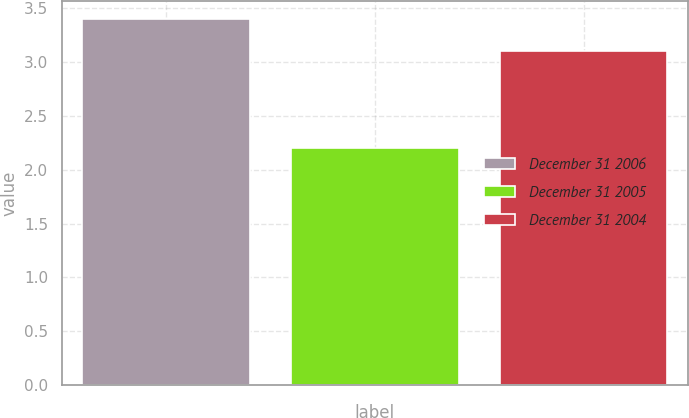<chart> <loc_0><loc_0><loc_500><loc_500><bar_chart><fcel>December 31 2006<fcel>December 31 2005<fcel>December 31 2004<nl><fcel>3.4<fcel>2.2<fcel>3.1<nl></chart> 